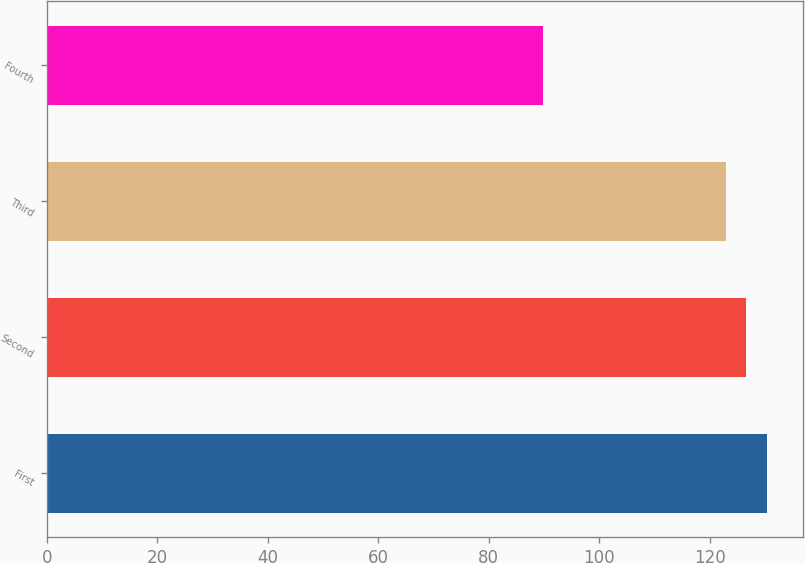Convert chart to OTSL. <chart><loc_0><loc_0><loc_500><loc_500><bar_chart><fcel>First<fcel>Second<fcel>Third<fcel>Fourth<nl><fcel>130.42<fcel>126.65<fcel>122.88<fcel>89.76<nl></chart> 